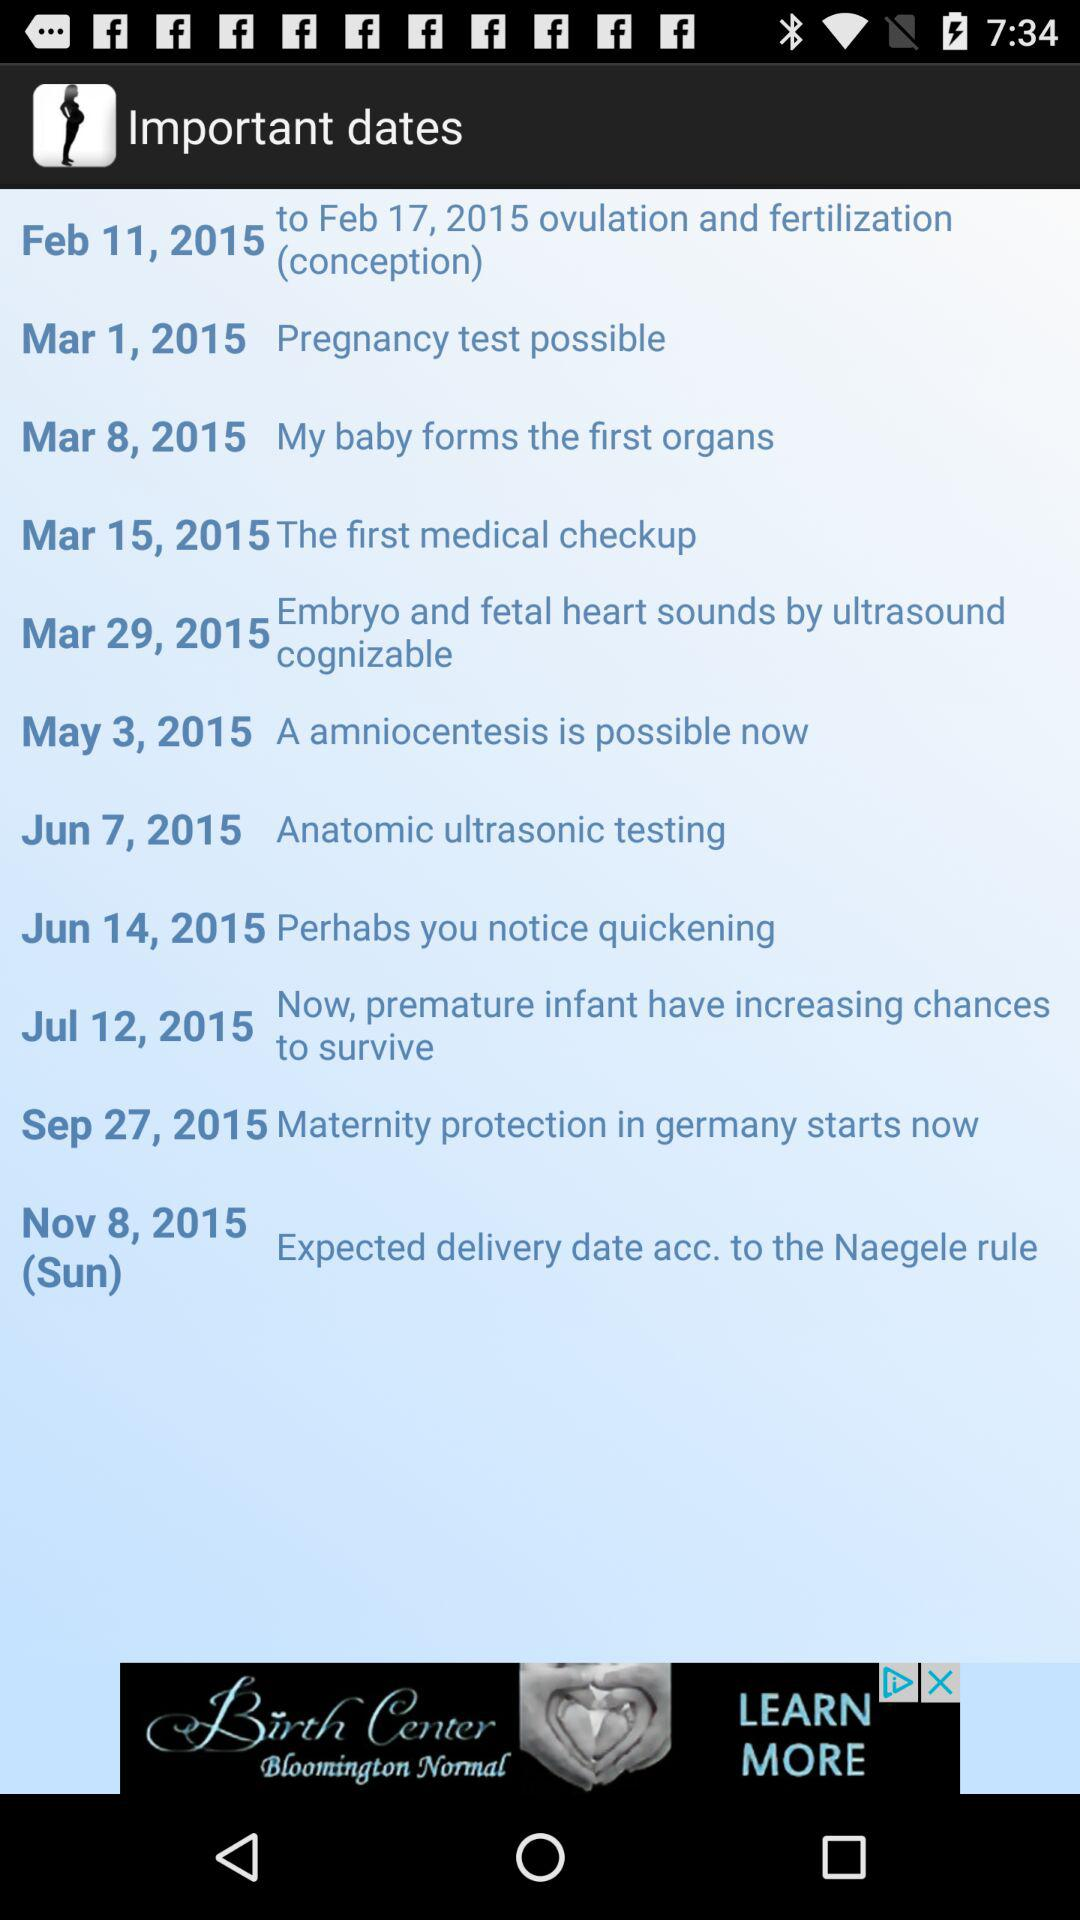What happened on March 1, 2015? On March 1, 2015, "Pregnancy test possible" appeared. 